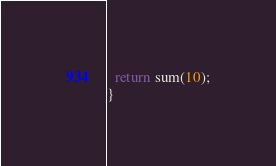<code> <loc_0><loc_0><loc_500><loc_500><_C_>  return sum(10);
}

</code> 